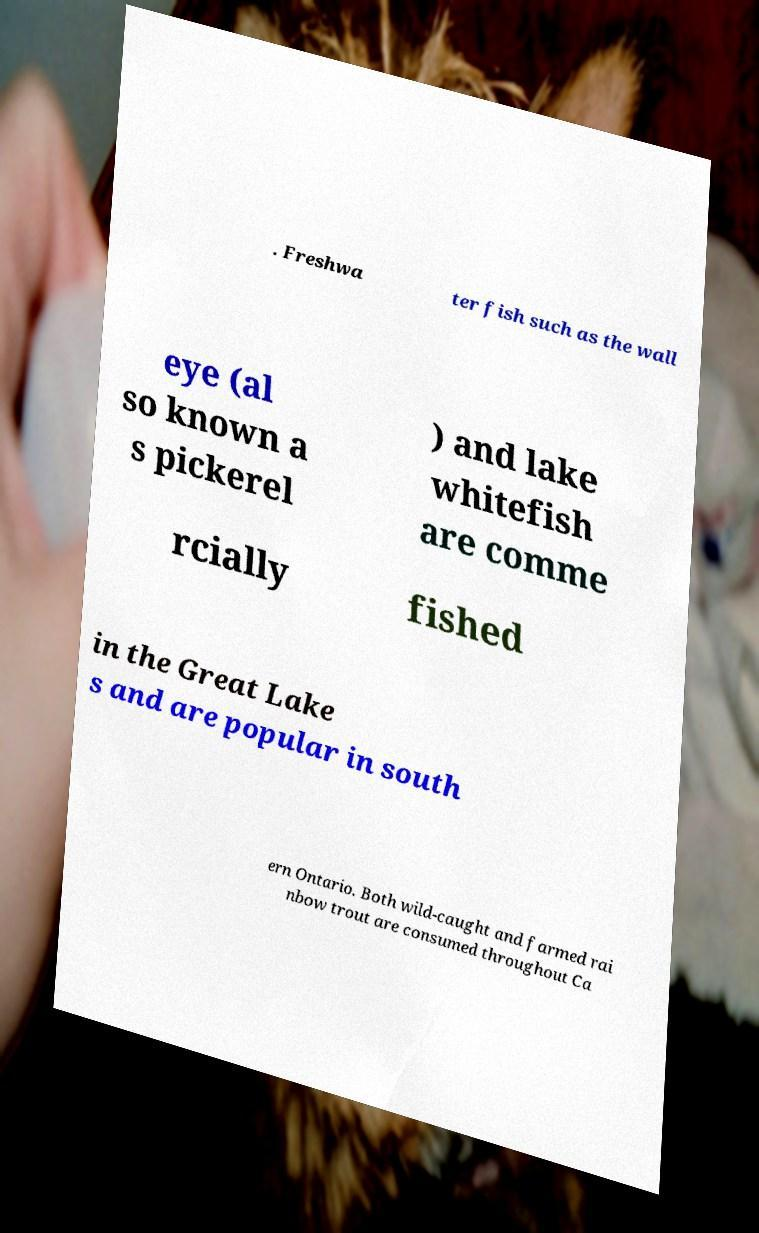For documentation purposes, I need the text within this image transcribed. Could you provide that? . Freshwa ter fish such as the wall eye (al so known a s pickerel ) and lake whitefish are comme rcially fished in the Great Lake s and are popular in south ern Ontario. Both wild-caught and farmed rai nbow trout are consumed throughout Ca 